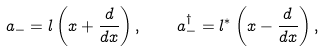Convert formula to latex. <formula><loc_0><loc_0><loc_500><loc_500>a _ { - } = l \left ( x + \frac { d } { d x } \right ) , \quad a _ { - } ^ { \dagger } = l ^ { \ast } \left ( x - \frac { d } { d x } \right ) ,</formula> 